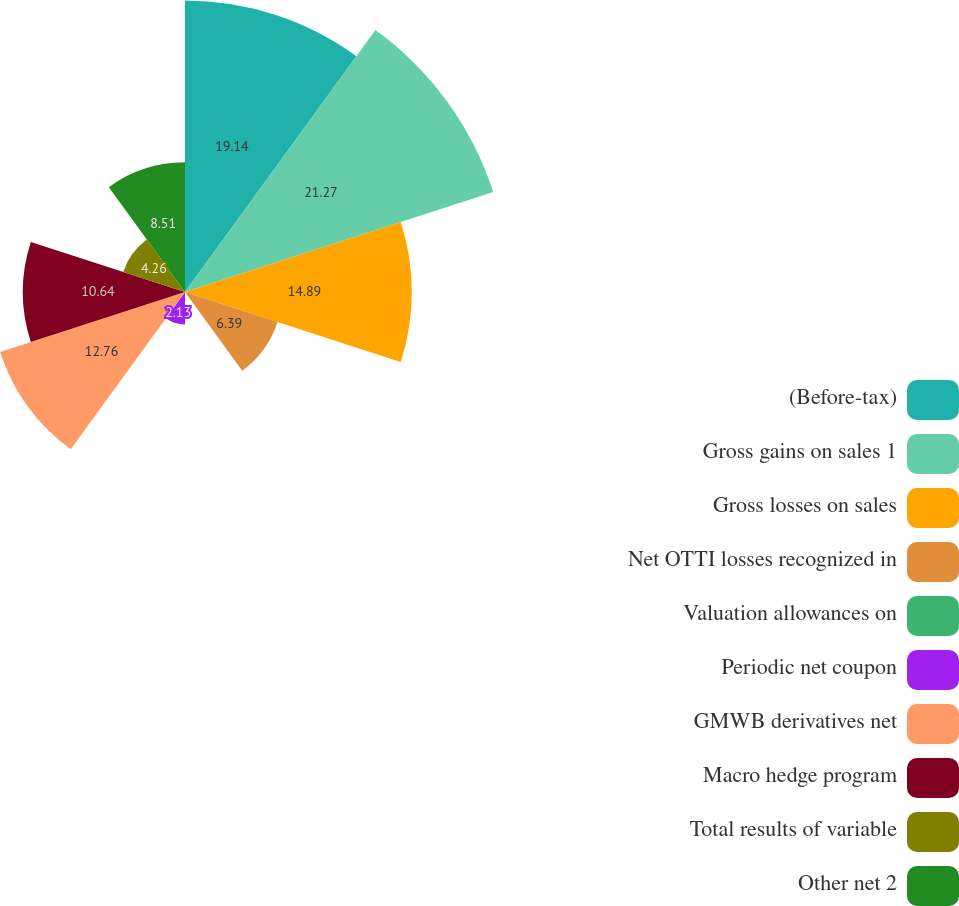Convert chart to OTSL. <chart><loc_0><loc_0><loc_500><loc_500><pie_chart><fcel>(Before-tax)<fcel>Gross gains on sales 1<fcel>Gross losses on sales<fcel>Net OTTI losses recognized in<fcel>Valuation allowances on<fcel>Periodic net coupon<fcel>GMWB derivatives net<fcel>Macro hedge program<fcel>Total results of variable<fcel>Other net 2<nl><fcel>19.14%<fcel>21.27%<fcel>14.89%<fcel>6.39%<fcel>0.01%<fcel>2.13%<fcel>12.76%<fcel>10.64%<fcel>4.26%<fcel>8.51%<nl></chart> 